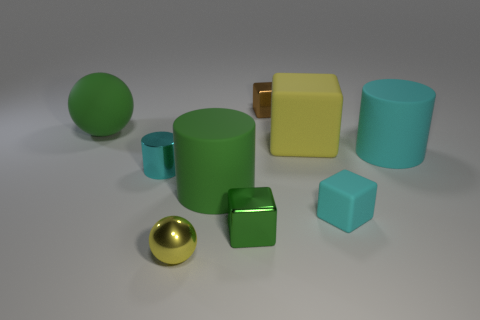Subtract all small blocks. How many blocks are left? 1 Add 1 tiny cylinders. How many objects exist? 10 Subtract all cyan cylinders. How many cylinders are left? 1 Subtract 4 blocks. How many blocks are left? 0 Subtract 0 blue cubes. How many objects are left? 9 Subtract all cubes. How many objects are left? 5 Subtract all cyan balls. Subtract all yellow blocks. How many balls are left? 2 Subtract all blue cylinders. How many green spheres are left? 1 Subtract all small cyan rubber things. Subtract all red shiny things. How many objects are left? 8 Add 6 small cyan blocks. How many small cyan blocks are left? 7 